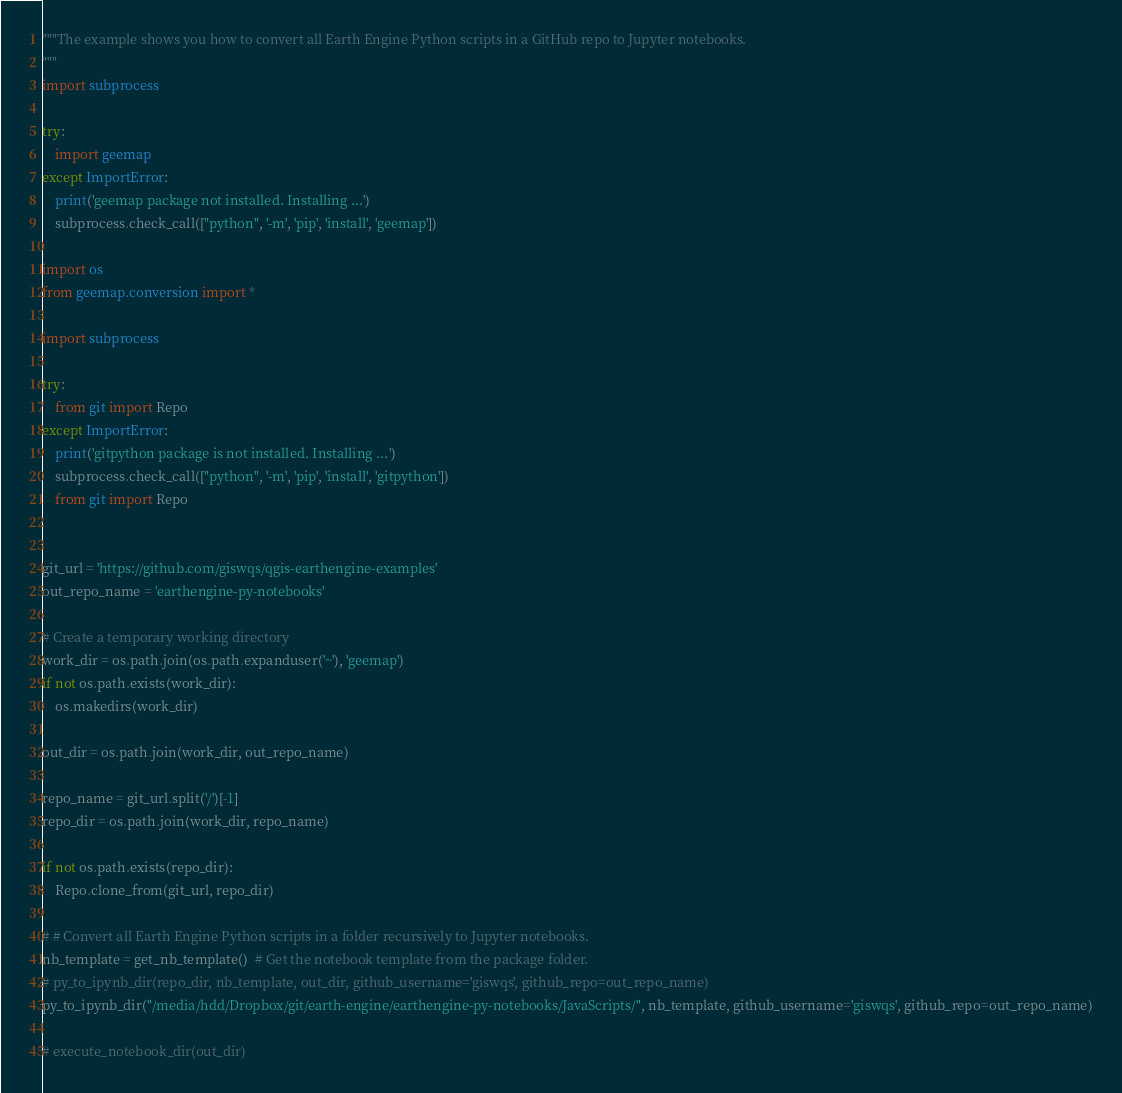Convert code to text. <code><loc_0><loc_0><loc_500><loc_500><_Python_>"""The example shows you how to convert all Earth Engine Python scripts in a GitHub repo to Jupyter notebooks.
"""
import subprocess

try:
    import geemap
except ImportError:
    print('geemap package not installed. Installing ...')
    subprocess.check_call(["python", '-m', 'pip', 'install', 'geemap'])

import os
from geemap.conversion import *

import subprocess

try:
    from git import Repo
except ImportError:
    print('gitpython package is not installed. Installing ...')
    subprocess.check_call(["python", '-m', 'pip', 'install', 'gitpython'])
    from git import Repo


git_url = 'https://github.com/giswqs/qgis-earthengine-examples'
out_repo_name = 'earthengine-py-notebooks'

# Create a temporary working directory
work_dir = os.path.join(os.path.expanduser('~'), 'geemap')
if not os.path.exists(work_dir):
    os.makedirs(work_dir)

out_dir = os.path.join(work_dir, out_repo_name)

repo_name = git_url.split('/')[-1]
repo_dir = os.path.join(work_dir, repo_name)

if not os.path.exists(repo_dir):
    Repo.clone_from(git_url, repo_dir)

# # Convert all Earth Engine Python scripts in a folder recursively to Jupyter notebooks.
nb_template = get_nb_template()  # Get the notebook template from the package folder.
# py_to_ipynb_dir(repo_dir, nb_template, out_dir, github_username='giswqs', github_repo=out_repo_name)
py_to_ipynb_dir("/media/hdd/Dropbox/git/earth-engine/earthengine-py-notebooks/JavaScripts/", nb_template, github_username='giswqs', github_repo=out_repo_name)

# execute_notebook_dir(out_dir)

</code> 